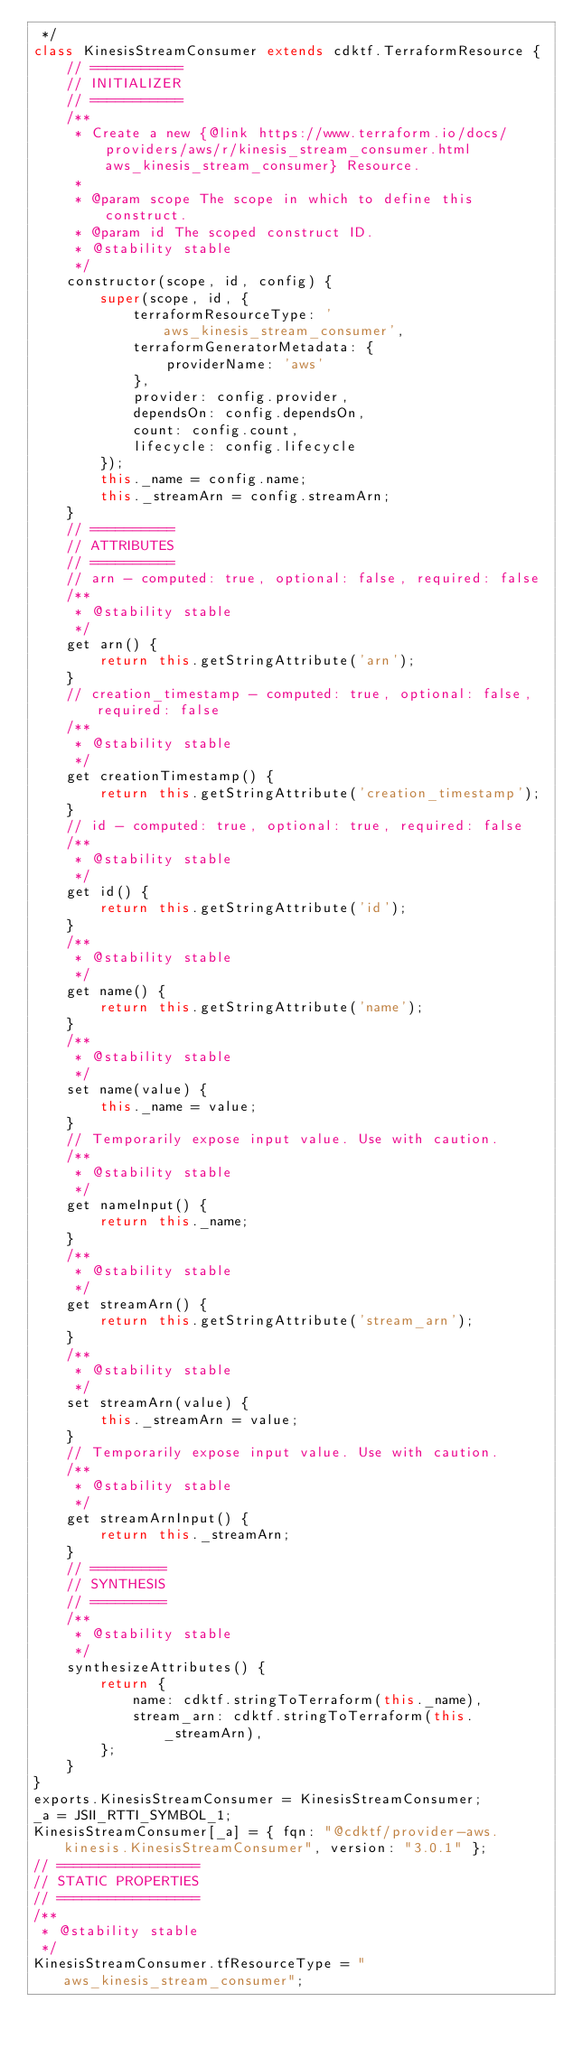<code> <loc_0><loc_0><loc_500><loc_500><_JavaScript_> */
class KinesisStreamConsumer extends cdktf.TerraformResource {
    // ===========
    // INITIALIZER
    // ===========
    /**
     * Create a new {@link https://www.terraform.io/docs/providers/aws/r/kinesis_stream_consumer.html aws_kinesis_stream_consumer} Resource.
     *
     * @param scope The scope in which to define this construct.
     * @param id The scoped construct ID.
     * @stability stable
     */
    constructor(scope, id, config) {
        super(scope, id, {
            terraformResourceType: 'aws_kinesis_stream_consumer',
            terraformGeneratorMetadata: {
                providerName: 'aws'
            },
            provider: config.provider,
            dependsOn: config.dependsOn,
            count: config.count,
            lifecycle: config.lifecycle
        });
        this._name = config.name;
        this._streamArn = config.streamArn;
    }
    // ==========
    // ATTRIBUTES
    // ==========
    // arn - computed: true, optional: false, required: false
    /**
     * @stability stable
     */
    get arn() {
        return this.getStringAttribute('arn');
    }
    // creation_timestamp - computed: true, optional: false, required: false
    /**
     * @stability stable
     */
    get creationTimestamp() {
        return this.getStringAttribute('creation_timestamp');
    }
    // id - computed: true, optional: true, required: false
    /**
     * @stability stable
     */
    get id() {
        return this.getStringAttribute('id');
    }
    /**
     * @stability stable
     */
    get name() {
        return this.getStringAttribute('name');
    }
    /**
     * @stability stable
     */
    set name(value) {
        this._name = value;
    }
    // Temporarily expose input value. Use with caution.
    /**
     * @stability stable
     */
    get nameInput() {
        return this._name;
    }
    /**
     * @stability stable
     */
    get streamArn() {
        return this.getStringAttribute('stream_arn');
    }
    /**
     * @stability stable
     */
    set streamArn(value) {
        this._streamArn = value;
    }
    // Temporarily expose input value. Use with caution.
    /**
     * @stability stable
     */
    get streamArnInput() {
        return this._streamArn;
    }
    // =========
    // SYNTHESIS
    // =========
    /**
     * @stability stable
     */
    synthesizeAttributes() {
        return {
            name: cdktf.stringToTerraform(this._name),
            stream_arn: cdktf.stringToTerraform(this._streamArn),
        };
    }
}
exports.KinesisStreamConsumer = KinesisStreamConsumer;
_a = JSII_RTTI_SYMBOL_1;
KinesisStreamConsumer[_a] = { fqn: "@cdktf/provider-aws.kinesis.KinesisStreamConsumer", version: "3.0.1" };
// =================
// STATIC PROPERTIES
// =================
/**
 * @stability stable
 */
KinesisStreamConsumer.tfResourceType = "aws_kinesis_stream_consumer";</code> 